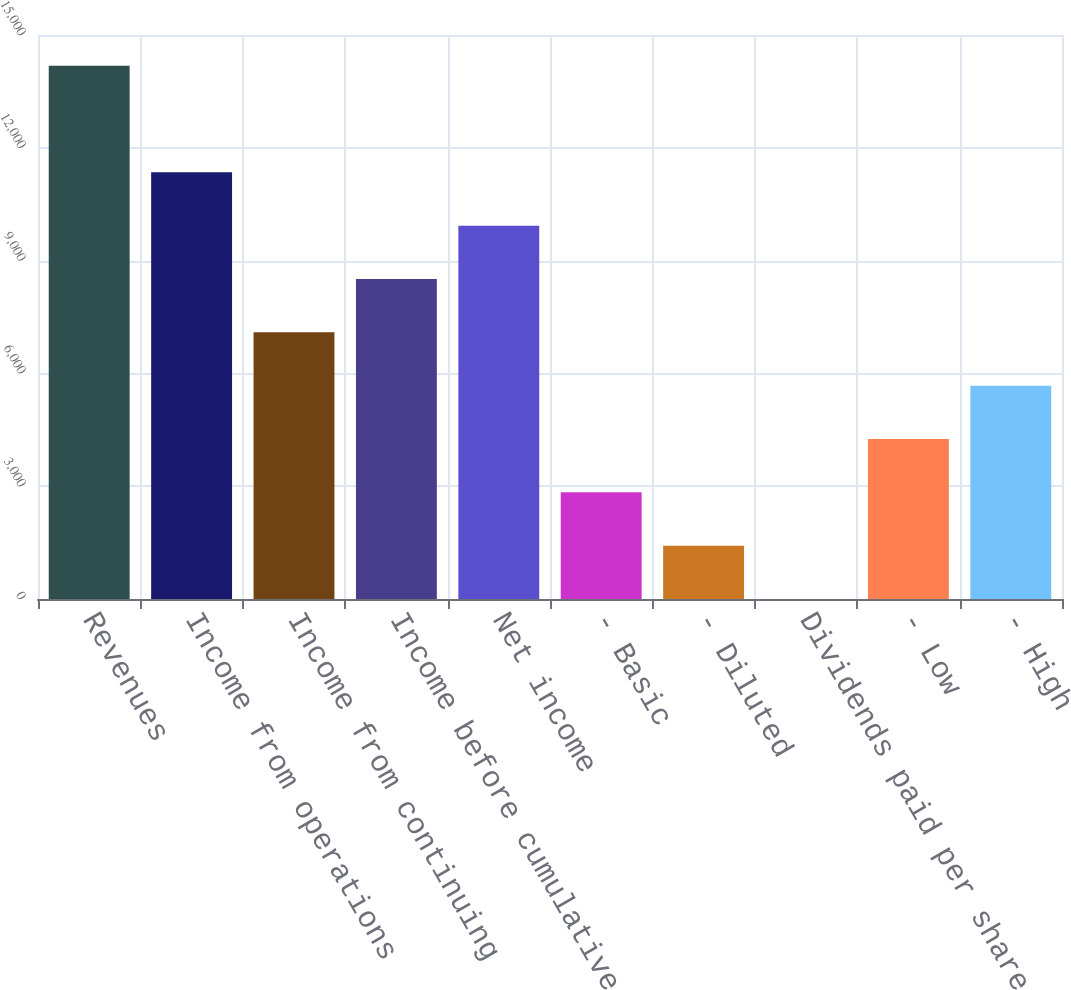Convert chart. <chart><loc_0><loc_0><loc_500><loc_500><bar_chart><fcel>Revenues<fcel>Income from operations<fcel>Income from continuing<fcel>Income before cumulative<fcel>Net income<fcel>- Basic<fcel>- Diluted<fcel>Dividends paid per share<fcel>- Low<fcel>- High<nl><fcel>14183<fcel>11346.4<fcel>7091.63<fcel>8509.9<fcel>9928.17<fcel>2836.82<fcel>1418.55<fcel>0.28<fcel>4255.09<fcel>5673.36<nl></chart> 